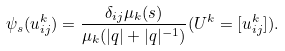Convert formula to latex. <formula><loc_0><loc_0><loc_500><loc_500>\psi _ { s } ( u _ { i j } ^ { k } ) = \frac { \delta _ { i j } \mu _ { k } ( s ) } { \mu _ { k } ( | q | + | q | ^ { - 1 } ) } ( U ^ { k } = [ u _ { i j } ^ { k } ] ) .</formula> 